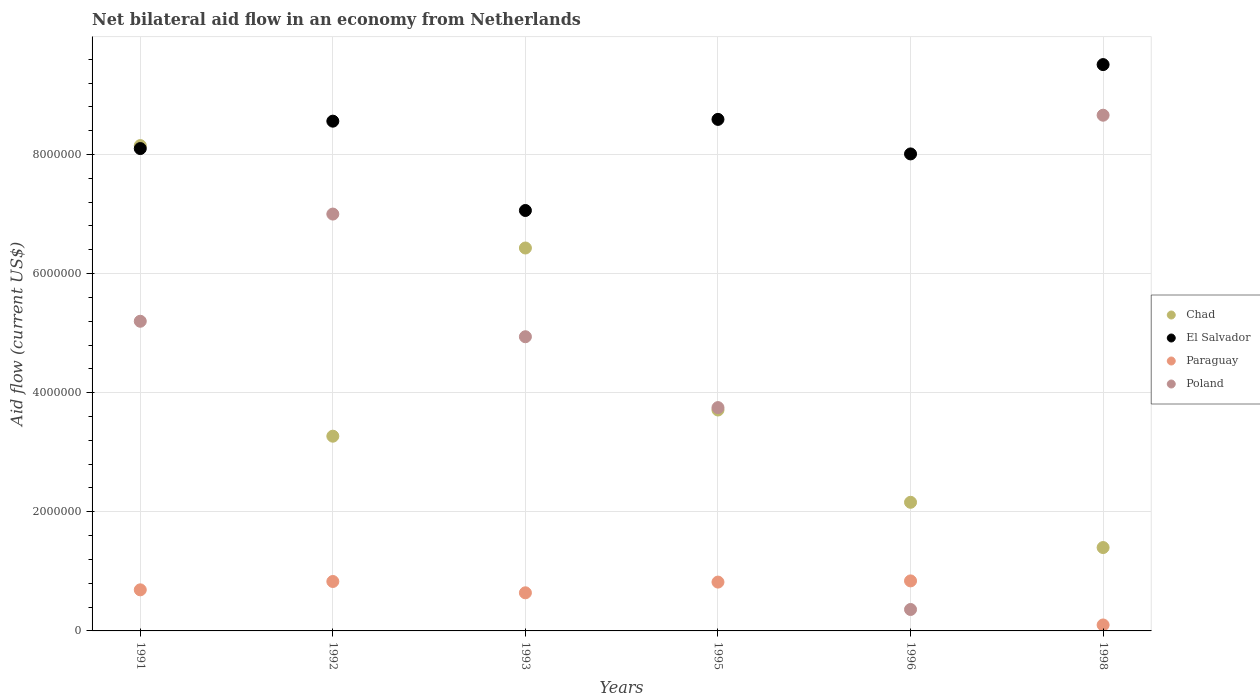How many different coloured dotlines are there?
Provide a succinct answer. 4. Is the number of dotlines equal to the number of legend labels?
Ensure brevity in your answer.  Yes. What is the net bilateral aid flow in Paraguay in 1993?
Offer a terse response. 6.40e+05. Across all years, what is the maximum net bilateral aid flow in Paraguay?
Your answer should be very brief. 8.40e+05. In which year was the net bilateral aid flow in Paraguay minimum?
Make the answer very short. 1998. What is the total net bilateral aid flow in Chad in the graph?
Give a very brief answer. 2.51e+07. What is the difference between the net bilateral aid flow in Poland in 1991 and that in 1992?
Provide a short and direct response. -1.80e+06. What is the average net bilateral aid flow in Chad per year?
Provide a succinct answer. 4.19e+06. In the year 1996, what is the difference between the net bilateral aid flow in Chad and net bilateral aid flow in Poland?
Your answer should be very brief. 1.80e+06. Is the net bilateral aid flow in Chad in 1992 less than that in 1996?
Provide a short and direct response. No. What is the difference between the highest and the second highest net bilateral aid flow in Chad?
Provide a succinct answer. 1.72e+06. What is the difference between the highest and the lowest net bilateral aid flow in El Salvador?
Your answer should be compact. 2.45e+06. In how many years, is the net bilateral aid flow in Paraguay greater than the average net bilateral aid flow in Paraguay taken over all years?
Offer a very short reply. 4. Is the sum of the net bilateral aid flow in Chad in 1991 and 1998 greater than the maximum net bilateral aid flow in El Salvador across all years?
Give a very brief answer. Yes. Is it the case that in every year, the sum of the net bilateral aid flow in Poland and net bilateral aid flow in Paraguay  is greater than the net bilateral aid flow in Chad?
Keep it short and to the point. No. Is the net bilateral aid flow in Chad strictly greater than the net bilateral aid flow in El Salvador over the years?
Offer a terse response. No. Is the net bilateral aid flow in Poland strictly less than the net bilateral aid flow in El Salvador over the years?
Give a very brief answer. Yes. Are the values on the major ticks of Y-axis written in scientific E-notation?
Keep it short and to the point. No. Where does the legend appear in the graph?
Provide a succinct answer. Center right. How many legend labels are there?
Your response must be concise. 4. What is the title of the graph?
Ensure brevity in your answer.  Net bilateral aid flow in an economy from Netherlands. What is the label or title of the Y-axis?
Offer a very short reply. Aid flow (current US$). What is the Aid flow (current US$) in Chad in 1991?
Keep it short and to the point. 8.15e+06. What is the Aid flow (current US$) of El Salvador in 1991?
Provide a succinct answer. 8.10e+06. What is the Aid flow (current US$) in Paraguay in 1991?
Offer a very short reply. 6.90e+05. What is the Aid flow (current US$) in Poland in 1991?
Offer a very short reply. 5.20e+06. What is the Aid flow (current US$) of Chad in 1992?
Ensure brevity in your answer.  3.27e+06. What is the Aid flow (current US$) of El Salvador in 1992?
Provide a succinct answer. 8.56e+06. What is the Aid flow (current US$) of Paraguay in 1992?
Your answer should be compact. 8.30e+05. What is the Aid flow (current US$) of Chad in 1993?
Keep it short and to the point. 6.43e+06. What is the Aid flow (current US$) of El Salvador in 1993?
Make the answer very short. 7.06e+06. What is the Aid flow (current US$) of Paraguay in 1993?
Provide a succinct answer. 6.40e+05. What is the Aid flow (current US$) of Poland in 1993?
Your answer should be compact. 4.94e+06. What is the Aid flow (current US$) in Chad in 1995?
Your answer should be compact. 3.71e+06. What is the Aid flow (current US$) of El Salvador in 1995?
Make the answer very short. 8.59e+06. What is the Aid flow (current US$) of Paraguay in 1995?
Keep it short and to the point. 8.20e+05. What is the Aid flow (current US$) in Poland in 1995?
Give a very brief answer. 3.75e+06. What is the Aid flow (current US$) of Chad in 1996?
Give a very brief answer. 2.16e+06. What is the Aid flow (current US$) in El Salvador in 1996?
Make the answer very short. 8.01e+06. What is the Aid flow (current US$) in Paraguay in 1996?
Offer a terse response. 8.40e+05. What is the Aid flow (current US$) of Poland in 1996?
Provide a short and direct response. 3.60e+05. What is the Aid flow (current US$) in Chad in 1998?
Offer a terse response. 1.40e+06. What is the Aid flow (current US$) of El Salvador in 1998?
Provide a short and direct response. 9.51e+06. What is the Aid flow (current US$) of Paraguay in 1998?
Keep it short and to the point. 1.00e+05. What is the Aid flow (current US$) of Poland in 1998?
Offer a terse response. 8.66e+06. Across all years, what is the maximum Aid flow (current US$) of Chad?
Offer a very short reply. 8.15e+06. Across all years, what is the maximum Aid flow (current US$) in El Salvador?
Provide a succinct answer. 9.51e+06. Across all years, what is the maximum Aid flow (current US$) of Paraguay?
Provide a succinct answer. 8.40e+05. Across all years, what is the maximum Aid flow (current US$) in Poland?
Provide a succinct answer. 8.66e+06. Across all years, what is the minimum Aid flow (current US$) of Chad?
Offer a terse response. 1.40e+06. Across all years, what is the minimum Aid flow (current US$) in El Salvador?
Your response must be concise. 7.06e+06. Across all years, what is the minimum Aid flow (current US$) of Paraguay?
Your answer should be compact. 1.00e+05. What is the total Aid flow (current US$) in Chad in the graph?
Your response must be concise. 2.51e+07. What is the total Aid flow (current US$) in El Salvador in the graph?
Your response must be concise. 4.98e+07. What is the total Aid flow (current US$) of Paraguay in the graph?
Your answer should be compact. 3.92e+06. What is the total Aid flow (current US$) of Poland in the graph?
Give a very brief answer. 2.99e+07. What is the difference between the Aid flow (current US$) of Chad in 1991 and that in 1992?
Your answer should be very brief. 4.88e+06. What is the difference between the Aid flow (current US$) in El Salvador in 1991 and that in 1992?
Your response must be concise. -4.60e+05. What is the difference between the Aid flow (current US$) in Paraguay in 1991 and that in 1992?
Keep it short and to the point. -1.40e+05. What is the difference between the Aid flow (current US$) in Poland in 1991 and that in 1992?
Provide a short and direct response. -1.80e+06. What is the difference between the Aid flow (current US$) in Chad in 1991 and that in 1993?
Provide a short and direct response. 1.72e+06. What is the difference between the Aid flow (current US$) of El Salvador in 1991 and that in 1993?
Offer a terse response. 1.04e+06. What is the difference between the Aid flow (current US$) in Poland in 1991 and that in 1993?
Provide a short and direct response. 2.60e+05. What is the difference between the Aid flow (current US$) in Chad in 1991 and that in 1995?
Keep it short and to the point. 4.44e+06. What is the difference between the Aid flow (current US$) of El Salvador in 1991 and that in 1995?
Offer a terse response. -4.90e+05. What is the difference between the Aid flow (current US$) of Poland in 1991 and that in 1995?
Your answer should be very brief. 1.45e+06. What is the difference between the Aid flow (current US$) in Chad in 1991 and that in 1996?
Provide a succinct answer. 5.99e+06. What is the difference between the Aid flow (current US$) in El Salvador in 1991 and that in 1996?
Offer a very short reply. 9.00e+04. What is the difference between the Aid flow (current US$) of Poland in 1991 and that in 1996?
Offer a terse response. 4.84e+06. What is the difference between the Aid flow (current US$) in Chad in 1991 and that in 1998?
Ensure brevity in your answer.  6.75e+06. What is the difference between the Aid flow (current US$) in El Salvador in 1991 and that in 1998?
Your answer should be compact. -1.41e+06. What is the difference between the Aid flow (current US$) in Paraguay in 1991 and that in 1998?
Provide a short and direct response. 5.90e+05. What is the difference between the Aid flow (current US$) of Poland in 1991 and that in 1998?
Your response must be concise. -3.46e+06. What is the difference between the Aid flow (current US$) of Chad in 1992 and that in 1993?
Your response must be concise. -3.16e+06. What is the difference between the Aid flow (current US$) in El Salvador in 1992 and that in 1993?
Ensure brevity in your answer.  1.50e+06. What is the difference between the Aid flow (current US$) of Paraguay in 1992 and that in 1993?
Provide a short and direct response. 1.90e+05. What is the difference between the Aid flow (current US$) in Poland in 1992 and that in 1993?
Keep it short and to the point. 2.06e+06. What is the difference between the Aid flow (current US$) of Chad in 1992 and that in 1995?
Make the answer very short. -4.40e+05. What is the difference between the Aid flow (current US$) in El Salvador in 1992 and that in 1995?
Provide a short and direct response. -3.00e+04. What is the difference between the Aid flow (current US$) of Paraguay in 1992 and that in 1995?
Give a very brief answer. 10000. What is the difference between the Aid flow (current US$) in Poland in 1992 and that in 1995?
Offer a terse response. 3.25e+06. What is the difference between the Aid flow (current US$) of Chad in 1992 and that in 1996?
Provide a short and direct response. 1.11e+06. What is the difference between the Aid flow (current US$) of El Salvador in 1992 and that in 1996?
Your answer should be compact. 5.50e+05. What is the difference between the Aid flow (current US$) of Paraguay in 1992 and that in 1996?
Make the answer very short. -10000. What is the difference between the Aid flow (current US$) in Poland in 1992 and that in 1996?
Make the answer very short. 6.64e+06. What is the difference between the Aid flow (current US$) in Chad in 1992 and that in 1998?
Keep it short and to the point. 1.87e+06. What is the difference between the Aid flow (current US$) in El Salvador in 1992 and that in 1998?
Your answer should be very brief. -9.50e+05. What is the difference between the Aid flow (current US$) of Paraguay in 1992 and that in 1998?
Ensure brevity in your answer.  7.30e+05. What is the difference between the Aid flow (current US$) in Poland in 1992 and that in 1998?
Ensure brevity in your answer.  -1.66e+06. What is the difference between the Aid flow (current US$) in Chad in 1993 and that in 1995?
Keep it short and to the point. 2.72e+06. What is the difference between the Aid flow (current US$) in El Salvador in 1993 and that in 1995?
Your answer should be compact. -1.53e+06. What is the difference between the Aid flow (current US$) of Paraguay in 1993 and that in 1995?
Keep it short and to the point. -1.80e+05. What is the difference between the Aid flow (current US$) of Poland in 1993 and that in 1995?
Your answer should be very brief. 1.19e+06. What is the difference between the Aid flow (current US$) in Chad in 1993 and that in 1996?
Your answer should be very brief. 4.27e+06. What is the difference between the Aid flow (current US$) in El Salvador in 1993 and that in 1996?
Provide a succinct answer. -9.50e+05. What is the difference between the Aid flow (current US$) of Paraguay in 1993 and that in 1996?
Provide a succinct answer. -2.00e+05. What is the difference between the Aid flow (current US$) in Poland in 1993 and that in 1996?
Your response must be concise. 4.58e+06. What is the difference between the Aid flow (current US$) of Chad in 1993 and that in 1998?
Make the answer very short. 5.03e+06. What is the difference between the Aid flow (current US$) of El Salvador in 1993 and that in 1998?
Offer a very short reply. -2.45e+06. What is the difference between the Aid flow (current US$) of Paraguay in 1993 and that in 1998?
Keep it short and to the point. 5.40e+05. What is the difference between the Aid flow (current US$) in Poland in 1993 and that in 1998?
Offer a very short reply. -3.72e+06. What is the difference between the Aid flow (current US$) of Chad in 1995 and that in 1996?
Keep it short and to the point. 1.55e+06. What is the difference between the Aid flow (current US$) of El Salvador in 1995 and that in 1996?
Your answer should be very brief. 5.80e+05. What is the difference between the Aid flow (current US$) of Paraguay in 1995 and that in 1996?
Make the answer very short. -2.00e+04. What is the difference between the Aid flow (current US$) in Poland in 1995 and that in 1996?
Your answer should be very brief. 3.39e+06. What is the difference between the Aid flow (current US$) in Chad in 1995 and that in 1998?
Your answer should be compact. 2.31e+06. What is the difference between the Aid flow (current US$) of El Salvador in 1995 and that in 1998?
Offer a terse response. -9.20e+05. What is the difference between the Aid flow (current US$) of Paraguay in 1995 and that in 1998?
Give a very brief answer. 7.20e+05. What is the difference between the Aid flow (current US$) in Poland in 1995 and that in 1998?
Keep it short and to the point. -4.91e+06. What is the difference between the Aid flow (current US$) in Chad in 1996 and that in 1998?
Your response must be concise. 7.60e+05. What is the difference between the Aid flow (current US$) in El Salvador in 1996 and that in 1998?
Give a very brief answer. -1.50e+06. What is the difference between the Aid flow (current US$) of Paraguay in 1996 and that in 1998?
Offer a very short reply. 7.40e+05. What is the difference between the Aid flow (current US$) in Poland in 1996 and that in 1998?
Provide a succinct answer. -8.30e+06. What is the difference between the Aid flow (current US$) of Chad in 1991 and the Aid flow (current US$) of El Salvador in 1992?
Provide a short and direct response. -4.10e+05. What is the difference between the Aid flow (current US$) of Chad in 1991 and the Aid flow (current US$) of Paraguay in 1992?
Make the answer very short. 7.32e+06. What is the difference between the Aid flow (current US$) of Chad in 1991 and the Aid flow (current US$) of Poland in 1992?
Your answer should be compact. 1.15e+06. What is the difference between the Aid flow (current US$) in El Salvador in 1991 and the Aid flow (current US$) in Paraguay in 1992?
Your answer should be compact. 7.27e+06. What is the difference between the Aid flow (current US$) in El Salvador in 1991 and the Aid flow (current US$) in Poland in 1992?
Your answer should be very brief. 1.10e+06. What is the difference between the Aid flow (current US$) in Paraguay in 1991 and the Aid flow (current US$) in Poland in 1992?
Offer a very short reply. -6.31e+06. What is the difference between the Aid flow (current US$) of Chad in 1991 and the Aid flow (current US$) of El Salvador in 1993?
Your answer should be very brief. 1.09e+06. What is the difference between the Aid flow (current US$) in Chad in 1991 and the Aid flow (current US$) in Paraguay in 1993?
Provide a succinct answer. 7.51e+06. What is the difference between the Aid flow (current US$) of Chad in 1991 and the Aid flow (current US$) of Poland in 1993?
Your answer should be compact. 3.21e+06. What is the difference between the Aid flow (current US$) in El Salvador in 1991 and the Aid flow (current US$) in Paraguay in 1993?
Provide a short and direct response. 7.46e+06. What is the difference between the Aid flow (current US$) of El Salvador in 1991 and the Aid flow (current US$) of Poland in 1993?
Your answer should be compact. 3.16e+06. What is the difference between the Aid flow (current US$) in Paraguay in 1991 and the Aid flow (current US$) in Poland in 1993?
Your response must be concise. -4.25e+06. What is the difference between the Aid flow (current US$) of Chad in 1991 and the Aid flow (current US$) of El Salvador in 1995?
Keep it short and to the point. -4.40e+05. What is the difference between the Aid flow (current US$) in Chad in 1991 and the Aid flow (current US$) in Paraguay in 1995?
Ensure brevity in your answer.  7.33e+06. What is the difference between the Aid flow (current US$) in Chad in 1991 and the Aid flow (current US$) in Poland in 1995?
Provide a succinct answer. 4.40e+06. What is the difference between the Aid flow (current US$) in El Salvador in 1991 and the Aid flow (current US$) in Paraguay in 1995?
Offer a very short reply. 7.28e+06. What is the difference between the Aid flow (current US$) of El Salvador in 1991 and the Aid flow (current US$) of Poland in 1995?
Provide a succinct answer. 4.35e+06. What is the difference between the Aid flow (current US$) of Paraguay in 1991 and the Aid flow (current US$) of Poland in 1995?
Make the answer very short. -3.06e+06. What is the difference between the Aid flow (current US$) in Chad in 1991 and the Aid flow (current US$) in Paraguay in 1996?
Provide a succinct answer. 7.31e+06. What is the difference between the Aid flow (current US$) of Chad in 1991 and the Aid flow (current US$) of Poland in 1996?
Keep it short and to the point. 7.79e+06. What is the difference between the Aid flow (current US$) of El Salvador in 1991 and the Aid flow (current US$) of Paraguay in 1996?
Your answer should be compact. 7.26e+06. What is the difference between the Aid flow (current US$) of El Salvador in 1991 and the Aid flow (current US$) of Poland in 1996?
Your response must be concise. 7.74e+06. What is the difference between the Aid flow (current US$) of Chad in 1991 and the Aid flow (current US$) of El Salvador in 1998?
Ensure brevity in your answer.  -1.36e+06. What is the difference between the Aid flow (current US$) of Chad in 1991 and the Aid flow (current US$) of Paraguay in 1998?
Offer a very short reply. 8.05e+06. What is the difference between the Aid flow (current US$) of Chad in 1991 and the Aid flow (current US$) of Poland in 1998?
Make the answer very short. -5.10e+05. What is the difference between the Aid flow (current US$) in El Salvador in 1991 and the Aid flow (current US$) in Poland in 1998?
Ensure brevity in your answer.  -5.60e+05. What is the difference between the Aid flow (current US$) of Paraguay in 1991 and the Aid flow (current US$) of Poland in 1998?
Your answer should be very brief. -7.97e+06. What is the difference between the Aid flow (current US$) in Chad in 1992 and the Aid flow (current US$) in El Salvador in 1993?
Provide a short and direct response. -3.79e+06. What is the difference between the Aid flow (current US$) in Chad in 1992 and the Aid flow (current US$) in Paraguay in 1993?
Offer a very short reply. 2.63e+06. What is the difference between the Aid flow (current US$) of Chad in 1992 and the Aid flow (current US$) of Poland in 1993?
Offer a very short reply. -1.67e+06. What is the difference between the Aid flow (current US$) of El Salvador in 1992 and the Aid flow (current US$) of Paraguay in 1993?
Give a very brief answer. 7.92e+06. What is the difference between the Aid flow (current US$) in El Salvador in 1992 and the Aid flow (current US$) in Poland in 1993?
Keep it short and to the point. 3.62e+06. What is the difference between the Aid flow (current US$) of Paraguay in 1992 and the Aid flow (current US$) of Poland in 1993?
Provide a short and direct response. -4.11e+06. What is the difference between the Aid flow (current US$) of Chad in 1992 and the Aid flow (current US$) of El Salvador in 1995?
Ensure brevity in your answer.  -5.32e+06. What is the difference between the Aid flow (current US$) of Chad in 1992 and the Aid flow (current US$) of Paraguay in 1995?
Your answer should be very brief. 2.45e+06. What is the difference between the Aid flow (current US$) of Chad in 1992 and the Aid flow (current US$) of Poland in 1995?
Your response must be concise. -4.80e+05. What is the difference between the Aid flow (current US$) in El Salvador in 1992 and the Aid flow (current US$) in Paraguay in 1995?
Offer a terse response. 7.74e+06. What is the difference between the Aid flow (current US$) in El Salvador in 1992 and the Aid flow (current US$) in Poland in 1995?
Make the answer very short. 4.81e+06. What is the difference between the Aid flow (current US$) in Paraguay in 1992 and the Aid flow (current US$) in Poland in 1995?
Provide a succinct answer. -2.92e+06. What is the difference between the Aid flow (current US$) in Chad in 1992 and the Aid flow (current US$) in El Salvador in 1996?
Provide a short and direct response. -4.74e+06. What is the difference between the Aid flow (current US$) in Chad in 1992 and the Aid flow (current US$) in Paraguay in 1996?
Keep it short and to the point. 2.43e+06. What is the difference between the Aid flow (current US$) in Chad in 1992 and the Aid flow (current US$) in Poland in 1996?
Make the answer very short. 2.91e+06. What is the difference between the Aid flow (current US$) of El Salvador in 1992 and the Aid flow (current US$) of Paraguay in 1996?
Keep it short and to the point. 7.72e+06. What is the difference between the Aid flow (current US$) in El Salvador in 1992 and the Aid flow (current US$) in Poland in 1996?
Your response must be concise. 8.20e+06. What is the difference between the Aid flow (current US$) in Paraguay in 1992 and the Aid flow (current US$) in Poland in 1996?
Your response must be concise. 4.70e+05. What is the difference between the Aid flow (current US$) in Chad in 1992 and the Aid flow (current US$) in El Salvador in 1998?
Provide a succinct answer. -6.24e+06. What is the difference between the Aid flow (current US$) in Chad in 1992 and the Aid flow (current US$) in Paraguay in 1998?
Provide a short and direct response. 3.17e+06. What is the difference between the Aid flow (current US$) of Chad in 1992 and the Aid flow (current US$) of Poland in 1998?
Your answer should be very brief. -5.39e+06. What is the difference between the Aid flow (current US$) of El Salvador in 1992 and the Aid flow (current US$) of Paraguay in 1998?
Give a very brief answer. 8.46e+06. What is the difference between the Aid flow (current US$) in El Salvador in 1992 and the Aid flow (current US$) in Poland in 1998?
Provide a short and direct response. -1.00e+05. What is the difference between the Aid flow (current US$) in Paraguay in 1992 and the Aid flow (current US$) in Poland in 1998?
Your answer should be compact. -7.83e+06. What is the difference between the Aid flow (current US$) in Chad in 1993 and the Aid flow (current US$) in El Salvador in 1995?
Ensure brevity in your answer.  -2.16e+06. What is the difference between the Aid flow (current US$) in Chad in 1993 and the Aid flow (current US$) in Paraguay in 1995?
Keep it short and to the point. 5.61e+06. What is the difference between the Aid flow (current US$) in Chad in 1993 and the Aid flow (current US$) in Poland in 1995?
Ensure brevity in your answer.  2.68e+06. What is the difference between the Aid flow (current US$) in El Salvador in 1993 and the Aid flow (current US$) in Paraguay in 1995?
Offer a terse response. 6.24e+06. What is the difference between the Aid flow (current US$) of El Salvador in 1993 and the Aid flow (current US$) of Poland in 1995?
Your answer should be compact. 3.31e+06. What is the difference between the Aid flow (current US$) in Paraguay in 1993 and the Aid flow (current US$) in Poland in 1995?
Your answer should be very brief. -3.11e+06. What is the difference between the Aid flow (current US$) in Chad in 1993 and the Aid flow (current US$) in El Salvador in 1996?
Give a very brief answer. -1.58e+06. What is the difference between the Aid flow (current US$) of Chad in 1993 and the Aid flow (current US$) of Paraguay in 1996?
Your answer should be compact. 5.59e+06. What is the difference between the Aid flow (current US$) of Chad in 1993 and the Aid flow (current US$) of Poland in 1996?
Your response must be concise. 6.07e+06. What is the difference between the Aid flow (current US$) of El Salvador in 1993 and the Aid flow (current US$) of Paraguay in 1996?
Make the answer very short. 6.22e+06. What is the difference between the Aid flow (current US$) in El Salvador in 1993 and the Aid flow (current US$) in Poland in 1996?
Offer a terse response. 6.70e+06. What is the difference between the Aid flow (current US$) in Paraguay in 1993 and the Aid flow (current US$) in Poland in 1996?
Make the answer very short. 2.80e+05. What is the difference between the Aid flow (current US$) of Chad in 1993 and the Aid flow (current US$) of El Salvador in 1998?
Keep it short and to the point. -3.08e+06. What is the difference between the Aid flow (current US$) in Chad in 1993 and the Aid flow (current US$) in Paraguay in 1998?
Your answer should be very brief. 6.33e+06. What is the difference between the Aid flow (current US$) in Chad in 1993 and the Aid flow (current US$) in Poland in 1998?
Provide a succinct answer. -2.23e+06. What is the difference between the Aid flow (current US$) in El Salvador in 1993 and the Aid flow (current US$) in Paraguay in 1998?
Your answer should be very brief. 6.96e+06. What is the difference between the Aid flow (current US$) of El Salvador in 1993 and the Aid flow (current US$) of Poland in 1998?
Ensure brevity in your answer.  -1.60e+06. What is the difference between the Aid flow (current US$) of Paraguay in 1993 and the Aid flow (current US$) of Poland in 1998?
Offer a very short reply. -8.02e+06. What is the difference between the Aid flow (current US$) in Chad in 1995 and the Aid flow (current US$) in El Salvador in 1996?
Give a very brief answer. -4.30e+06. What is the difference between the Aid flow (current US$) in Chad in 1995 and the Aid flow (current US$) in Paraguay in 1996?
Your response must be concise. 2.87e+06. What is the difference between the Aid flow (current US$) of Chad in 1995 and the Aid flow (current US$) of Poland in 1996?
Give a very brief answer. 3.35e+06. What is the difference between the Aid flow (current US$) of El Salvador in 1995 and the Aid flow (current US$) of Paraguay in 1996?
Your answer should be very brief. 7.75e+06. What is the difference between the Aid flow (current US$) of El Salvador in 1995 and the Aid flow (current US$) of Poland in 1996?
Keep it short and to the point. 8.23e+06. What is the difference between the Aid flow (current US$) in Chad in 1995 and the Aid flow (current US$) in El Salvador in 1998?
Make the answer very short. -5.80e+06. What is the difference between the Aid flow (current US$) of Chad in 1995 and the Aid flow (current US$) of Paraguay in 1998?
Offer a terse response. 3.61e+06. What is the difference between the Aid flow (current US$) of Chad in 1995 and the Aid flow (current US$) of Poland in 1998?
Offer a terse response. -4.95e+06. What is the difference between the Aid flow (current US$) in El Salvador in 1995 and the Aid flow (current US$) in Paraguay in 1998?
Offer a very short reply. 8.49e+06. What is the difference between the Aid flow (current US$) of Paraguay in 1995 and the Aid flow (current US$) of Poland in 1998?
Ensure brevity in your answer.  -7.84e+06. What is the difference between the Aid flow (current US$) in Chad in 1996 and the Aid flow (current US$) in El Salvador in 1998?
Make the answer very short. -7.35e+06. What is the difference between the Aid flow (current US$) of Chad in 1996 and the Aid flow (current US$) of Paraguay in 1998?
Provide a succinct answer. 2.06e+06. What is the difference between the Aid flow (current US$) of Chad in 1996 and the Aid flow (current US$) of Poland in 1998?
Keep it short and to the point. -6.50e+06. What is the difference between the Aid flow (current US$) of El Salvador in 1996 and the Aid flow (current US$) of Paraguay in 1998?
Give a very brief answer. 7.91e+06. What is the difference between the Aid flow (current US$) of El Salvador in 1996 and the Aid flow (current US$) of Poland in 1998?
Your response must be concise. -6.50e+05. What is the difference between the Aid flow (current US$) of Paraguay in 1996 and the Aid flow (current US$) of Poland in 1998?
Give a very brief answer. -7.82e+06. What is the average Aid flow (current US$) of Chad per year?
Your answer should be very brief. 4.19e+06. What is the average Aid flow (current US$) of El Salvador per year?
Offer a terse response. 8.30e+06. What is the average Aid flow (current US$) in Paraguay per year?
Your answer should be very brief. 6.53e+05. What is the average Aid flow (current US$) of Poland per year?
Offer a very short reply. 4.98e+06. In the year 1991, what is the difference between the Aid flow (current US$) in Chad and Aid flow (current US$) in El Salvador?
Give a very brief answer. 5.00e+04. In the year 1991, what is the difference between the Aid flow (current US$) of Chad and Aid flow (current US$) of Paraguay?
Provide a succinct answer. 7.46e+06. In the year 1991, what is the difference between the Aid flow (current US$) in Chad and Aid flow (current US$) in Poland?
Provide a succinct answer. 2.95e+06. In the year 1991, what is the difference between the Aid flow (current US$) in El Salvador and Aid flow (current US$) in Paraguay?
Provide a succinct answer. 7.41e+06. In the year 1991, what is the difference between the Aid flow (current US$) of El Salvador and Aid flow (current US$) of Poland?
Your response must be concise. 2.90e+06. In the year 1991, what is the difference between the Aid flow (current US$) in Paraguay and Aid flow (current US$) in Poland?
Offer a very short reply. -4.51e+06. In the year 1992, what is the difference between the Aid flow (current US$) in Chad and Aid flow (current US$) in El Salvador?
Offer a terse response. -5.29e+06. In the year 1992, what is the difference between the Aid flow (current US$) in Chad and Aid flow (current US$) in Paraguay?
Give a very brief answer. 2.44e+06. In the year 1992, what is the difference between the Aid flow (current US$) of Chad and Aid flow (current US$) of Poland?
Offer a terse response. -3.73e+06. In the year 1992, what is the difference between the Aid flow (current US$) of El Salvador and Aid flow (current US$) of Paraguay?
Offer a terse response. 7.73e+06. In the year 1992, what is the difference between the Aid flow (current US$) of El Salvador and Aid flow (current US$) of Poland?
Provide a short and direct response. 1.56e+06. In the year 1992, what is the difference between the Aid flow (current US$) of Paraguay and Aid flow (current US$) of Poland?
Provide a succinct answer. -6.17e+06. In the year 1993, what is the difference between the Aid flow (current US$) in Chad and Aid flow (current US$) in El Salvador?
Provide a short and direct response. -6.30e+05. In the year 1993, what is the difference between the Aid flow (current US$) of Chad and Aid flow (current US$) of Paraguay?
Provide a succinct answer. 5.79e+06. In the year 1993, what is the difference between the Aid flow (current US$) of Chad and Aid flow (current US$) of Poland?
Make the answer very short. 1.49e+06. In the year 1993, what is the difference between the Aid flow (current US$) in El Salvador and Aid flow (current US$) in Paraguay?
Give a very brief answer. 6.42e+06. In the year 1993, what is the difference between the Aid flow (current US$) of El Salvador and Aid flow (current US$) of Poland?
Make the answer very short. 2.12e+06. In the year 1993, what is the difference between the Aid flow (current US$) in Paraguay and Aid flow (current US$) in Poland?
Keep it short and to the point. -4.30e+06. In the year 1995, what is the difference between the Aid flow (current US$) in Chad and Aid flow (current US$) in El Salvador?
Ensure brevity in your answer.  -4.88e+06. In the year 1995, what is the difference between the Aid flow (current US$) in Chad and Aid flow (current US$) in Paraguay?
Provide a short and direct response. 2.89e+06. In the year 1995, what is the difference between the Aid flow (current US$) in El Salvador and Aid flow (current US$) in Paraguay?
Keep it short and to the point. 7.77e+06. In the year 1995, what is the difference between the Aid flow (current US$) in El Salvador and Aid flow (current US$) in Poland?
Your response must be concise. 4.84e+06. In the year 1995, what is the difference between the Aid flow (current US$) of Paraguay and Aid flow (current US$) of Poland?
Offer a terse response. -2.93e+06. In the year 1996, what is the difference between the Aid flow (current US$) of Chad and Aid flow (current US$) of El Salvador?
Offer a very short reply. -5.85e+06. In the year 1996, what is the difference between the Aid flow (current US$) of Chad and Aid flow (current US$) of Paraguay?
Provide a succinct answer. 1.32e+06. In the year 1996, what is the difference between the Aid flow (current US$) of Chad and Aid flow (current US$) of Poland?
Give a very brief answer. 1.80e+06. In the year 1996, what is the difference between the Aid flow (current US$) in El Salvador and Aid flow (current US$) in Paraguay?
Ensure brevity in your answer.  7.17e+06. In the year 1996, what is the difference between the Aid flow (current US$) of El Salvador and Aid flow (current US$) of Poland?
Offer a terse response. 7.65e+06. In the year 1996, what is the difference between the Aid flow (current US$) of Paraguay and Aid flow (current US$) of Poland?
Offer a very short reply. 4.80e+05. In the year 1998, what is the difference between the Aid flow (current US$) of Chad and Aid flow (current US$) of El Salvador?
Your response must be concise. -8.11e+06. In the year 1998, what is the difference between the Aid flow (current US$) of Chad and Aid flow (current US$) of Paraguay?
Provide a succinct answer. 1.30e+06. In the year 1998, what is the difference between the Aid flow (current US$) of Chad and Aid flow (current US$) of Poland?
Give a very brief answer. -7.26e+06. In the year 1998, what is the difference between the Aid flow (current US$) in El Salvador and Aid flow (current US$) in Paraguay?
Offer a very short reply. 9.41e+06. In the year 1998, what is the difference between the Aid flow (current US$) of El Salvador and Aid flow (current US$) of Poland?
Provide a short and direct response. 8.50e+05. In the year 1998, what is the difference between the Aid flow (current US$) of Paraguay and Aid flow (current US$) of Poland?
Make the answer very short. -8.56e+06. What is the ratio of the Aid flow (current US$) in Chad in 1991 to that in 1992?
Your answer should be compact. 2.49. What is the ratio of the Aid flow (current US$) in El Salvador in 1991 to that in 1992?
Give a very brief answer. 0.95. What is the ratio of the Aid flow (current US$) of Paraguay in 1991 to that in 1992?
Your response must be concise. 0.83. What is the ratio of the Aid flow (current US$) in Poland in 1991 to that in 1992?
Your answer should be compact. 0.74. What is the ratio of the Aid flow (current US$) in Chad in 1991 to that in 1993?
Provide a short and direct response. 1.27. What is the ratio of the Aid flow (current US$) in El Salvador in 1991 to that in 1993?
Make the answer very short. 1.15. What is the ratio of the Aid flow (current US$) of Paraguay in 1991 to that in 1993?
Provide a short and direct response. 1.08. What is the ratio of the Aid flow (current US$) in Poland in 1991 to that in 1993?
Provide a short and direct response. 1.05. What is the ratio of the Aid flow (current US$) of Chad in 1991 to that in 1995?
Make the answer very short. 2.2. What is the ratio of the Aid flow (current US$) in El Salvador in 1991 to that in 1995?
Offer a terse response. 0.94. What is the ratio of the Aid flow (current US$) of Paraguay in 1991 to that in 1995?
Make the answer very short. 0.84. What is the ratio of the Aid flow (current US$) of Poland in 1991 to that in 1995?
Your response must be concise. 1.39. What is the ratio of the Aid flow (current US$) of Chad in 1991 to that in 1996?
Your response must be concise. 3.77. What is the ratio of the Aid flow (current US$) in El Salvador in 1991 to that in 1996?
Provide a short and direct response. 1.01. What is the ratio of the Aid flow (current US$) in Paraguay in 1991 to that in 1996?
Your response must be concise. 0.82. What is the ratio of the Aid flow (current US$) in Poland in 1991 to that in 1996?
Offer a terse response. 14.44. What is the ratio of the Aid flow (current US$) of Chad in 1991 to that in 1998?
Make the answer very short. 5.82. What is the ratio of the Aid flow (current US$) in El Salvador in 1991 to that in 1998?
Your response must be concise. 0.85. What is the ratio of the Aid flow (current US$) of Paraguay in 1991 to that in 1998?
Provide a succinct answer. 6.9. What is the ratio of the Aid flow (current US$) in Poland in 1991 to that in 1998?
Offer a very short reply. 0.6. What is the ratio of the Aid flow (current US$) in Chad in 1992 to that in 1993?
Your response must be concise. 0.51. What is the ratio of the Aid flow (current US$) of El Salvador in 1992 to that in 1993?
Your answer should be very brief. 1.21. What is the ratio of the Aid flow (current US$) in Paraguay in 1992 to that in 1993?
Ensure brevity in your answer.  1.3. What is the ratio of the Aid flow (current US$) in Poland in 1992 to that in 1993?
Make the answer very short. 1.42. What is the ratio of the Aid flow (current US$) in Chad in 1992 to that in 1995?
Provide a short and direct response. 0.88. What is the ratio of the Aid flow (current US$) in El Salvador in 1992 to that in 1995?
Make the answer very short. 1. What is the ratio of the Aid flow (current US$) of Paraguay in 1992 to that in 1995?
Provide a succinct answer. 1.01. What is the ratio of the Aid flow (current US$) in Poland in 1992 to that in 1995?
Provide a succinct answer. 1.87. What is the ratio of the Aid flow (current US$) in Chad in 1992 to that in 1996?
Your answer should be compact. 1.51. What is the ratio of the Aid flow (current US$) of El Salvador in 1992 to that in 1996?
Offer a terse response. 1.07. What is the ratio of the Aid flow (current US$) in Poland in 1992 to that in 1996?
Provide a succinct answer. 19.44. What is the ratio of the Aid flow (current US$) in Chad in 1992 to that in 1998?
Your answer should be very brief. 2.34. What is the ratio of the Aid flow (current US$) in El Salvador in 1992 to that in 1998?
Provide a short and direct response. 0.9. What is the ratio of the Aid flow (current US$) of Paraguay in 1992 to that in 1998?
Make the answer very short. 8.3. What is the ratio of the Aid flow (current US$) in Poland in 1992 to that in 1998?
Your answer should be very brief. 0.81. What is the ratio of the Aid flow (current US$) in Chad in 1993 to that in 1995?
Offer a very short reply. 1.73. What is the ratio of the Aid flow (current US$) in El Salvador in 1993 to that in 1995?
Your answer should be very brief. 0.82. What is the ratio of the Aid flow (current US$) of Paraguay in 1993 to that in 1995?
Your answer should be very brief. 0.78. What is the ratio of the Aid flow (current US$) in Poland in 1993 to that in 1995?
Your answer should be compact. 1.32. What is the ratio of the Aid flow (current US$) in Chad in 1993 to that in 1996?
Ensure brevity in your answer.  2.98. What is the ratio of the Aid flow (current US$) of El Salvador in 1993 to that in 1996?
Ensure brevity in your answer.  0.88. What is the ratio of the Aid flow (current US$) of Paraguay in 1993 to that in 1996?
Offer a terse response. 0.76. What is the ratio of the Aid flow (current US$) in Poland in 1993 to that in 1996?
Your answer should be compact. 13.72. What is the ratio of the Aid flow (current US$) in Chad in 1993 to that in 1998?
Keep it short and to the point. 4.59. What is the ratio of the Aid flow (current US$) in El Salvador in 1993 to that in 1998?
Your answer should be very brief. 0.74. What is the ratio of the Aid flow (current US$) in Paraguay in 1993 to that in 1998?
Your response must be concise. 6.4. What is the ratio of the Aid flow (current US$) in Poland in 1993 to that in 1998?
Offer a terse response. 0.57. What is the ratio of the Aid flow (current US$) in Chad in 1995 to that in 1996?
Your answer should be very brief. 1.72. What is the ratio of the Aid flow (current US$) of El Salvador in 1995 to that in 1996?
Your response must be concise. 1.07. What is the ratio of the Aid flow (current US$) in Paraguay in 1995 to that in 1996?
Provide a succinct answer. 0.98. What is the ratio of the Aid flow (current US$) of Poland in 1995 to that in 1996?
Ensure brevity in your answer.  10.42. What is the ratio of the Aid flow (current US$) of Chad in 1995 to that in 1998?
Make the answer very short. 2.65. What is the ratio of the Aid flow (current US$) in El Salvador in 1995 to that in 1998?
Provide a short and direct response. 0.9. What is the ratio of the Aid flow (current US$) in Paraguay in 1995 to that in 1998?
Your answer should be very brief. 8.2. What is the ratio of the Aid flow (current US$) of Poland in 1995 to that in 1998?
Ensure brevity in your answer.  0.43. What is the ratio of the Aid flow (current US$) of Chad in 1996 to that in 1998?
Provide a succinct answer. 1.54. What is the ratio of the Aid flow (current US$) of El Salvador in 1996 to that in 1998?
Offer a terse response. 0.84. What is the ratio of the Aid flow (current US$) in Paraguay in 1996 to that in 1998?
Provide a short and direct response. 8.4. What is the ratio of the Aid flow (current US$) of Poland in 1996 to that in 1998?
Give a very brief answer. 0.04. What is the difference between the highest and the second highest Aid flow (current US$) of Chad?
Make the answer very short. 1.72e+06. What is the difference between the highest and the second highest Aid flow (current US$) in El Salvador?
Make the answer very short. 9.20e+05. What is the difference between the highest and the second highest Aid flow (current US$) in Paraguay?
Make the answer very short. 10000. What is the difference between the highest and the second highest Aid flow (current US$) of Poland?
Offer a terse response. 1.66e+06. What is the difference between the highest and the lowest Aid flow (current US$) of Chad?
Your response must be concise. 6.75e+06. What is the difference between the highest and the lowest Aid flow (current US$) in El Salvador?
Your answer should be compact. 2.45e+06. What is the difference between the highest and the lowest Aid flow (current US$) in Paraguay?
Provide a short and direct response. 7.40e+05. What is the difference between the highest and the lowest Aid flow (current US$) of Poland?
Your answer should be very brief. 8.30e+06. 